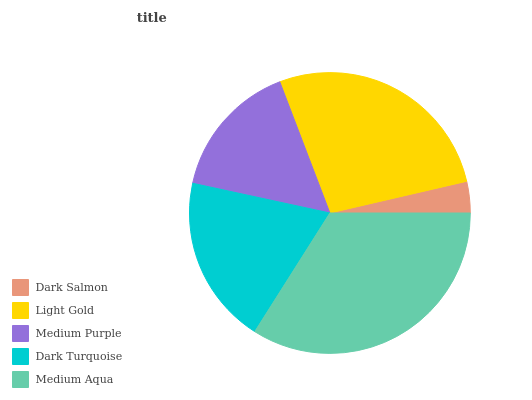Is Dark Salmon the minimum?
Answer yes or no. Yes. Is Medium Aqua the maximum?
Answer yes or no. Yes. Is Light Gold the minimum?
Answer yes or no. No. Is Light Gold the maximum?
Answer yes or no. No. Is Light Gold greater than Dark Salmon?
Answer yes or no. Yes. Is Dark Salmon less than Light Gold?
Answer yes or no. Yes. Is Dark Salmon greater than Light Gold?
Answer yes or no. No. Is Light Gold less than Dark Salmon?
Answer yes or no. No. Is Dark Turquoise the high median?
Answer yes or no. Yes. Is Dark Turquoise the low median?
Answer yes or no. Yes. Is Medium Aqua the high median?
Answer yes or no. No. Is Medium Purple the low median?
Answer yes or no. No. 